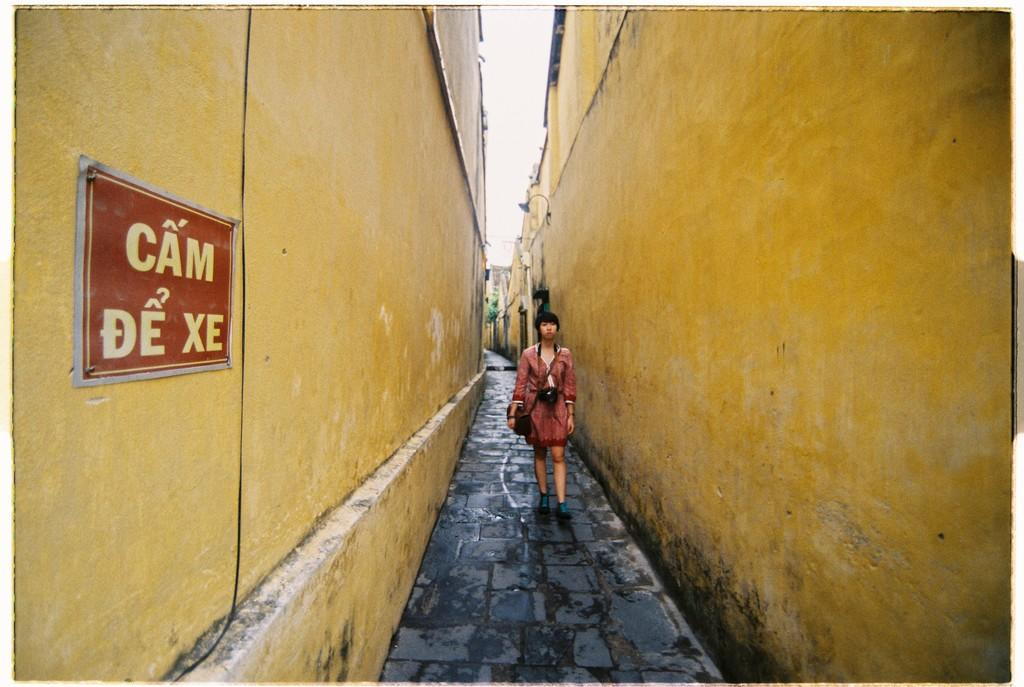<image>
Give a short and clear explanation of the subsequent image. a small road with walls with one that has a sign that says 'cam de xe' 